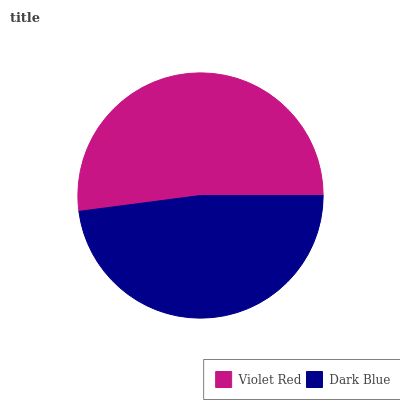Is Dark Blue the minimum?
Answer yes or no. Yes. Is Violet Red the maximum?
Answer yes or no. Yes. Is Dark Blue the maximum?
Answer yes or no. No. Is Violet Red greater than Dark Blue?
Answer yes or no. Yes. Is Dark Blue less than Violet Red?
Answer yes or no. Yes. Is Dark Blue greater than Violet Red?
Answer yes or no. No. Is Violet Red less than Dark Blue?
Answer yes or no. No. Is Violet Red the high median?
Answer yes or no. Yes. Is Dark Blue the low median?
Answer yes or no. Yes. Is Dark Blue the high median?
Answer yes or no. No. Is Violet Red the low median?
Answer yes or no. No. 